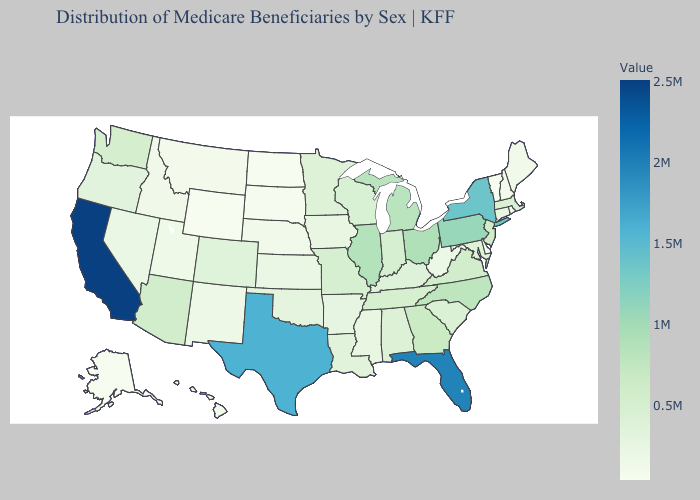Among the states that border Florida , which have the lowest value?
Give a very brief answer. Alabama. Does California have the highest value in the West?
Short answer required. Yes. Does Washington have a higher value than Alaska?
Quick response, please. Yes. Among the states that border New Mexico , which have the highest value?
Keep it brief. Texas. Does California have the highest value in the USA?
Answer briefly. Yes. Does Alaska have the lowest value in the USA?
Short answer required. Yes. Does the map have missing data?
Quick response, please. No. 